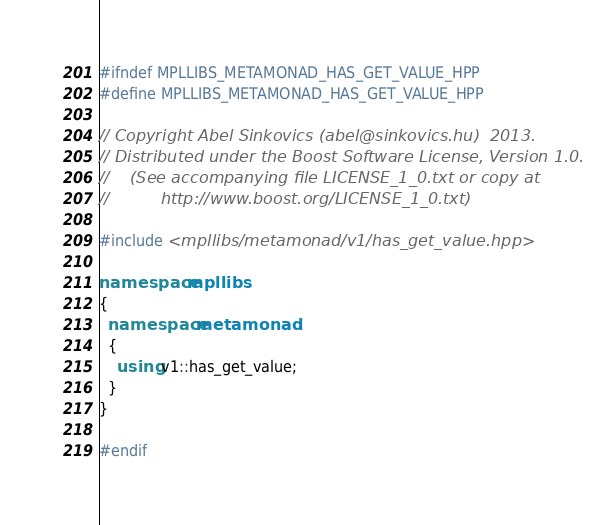Convert code to text. <code><loc_0><loc_0><loc_500><loc_500><_C++_>#ifndef MPLLIBS_METAMONAD_HAS_GET_VALUE_HPP
#define MPLLIBS_METAMONAD_HAS_GET_VALUE_HPP

// Copyright Abel Sinkovics (abel@sinkovics.hu)  2013.
// Distributed under the Boost Software License, Version 1.0.
//    (See accompanying file LICENSE_1_0.txt or copy at
//          http://www.boost.org/LICENSE_1_0.txt)

#include <mpllibs/metamonad/v1/has_get_value.hpp>

namespace mpllibs
{
  namespace metamonad
  {
    using v1::has_get_value;
  }
}

#endif

</code> 